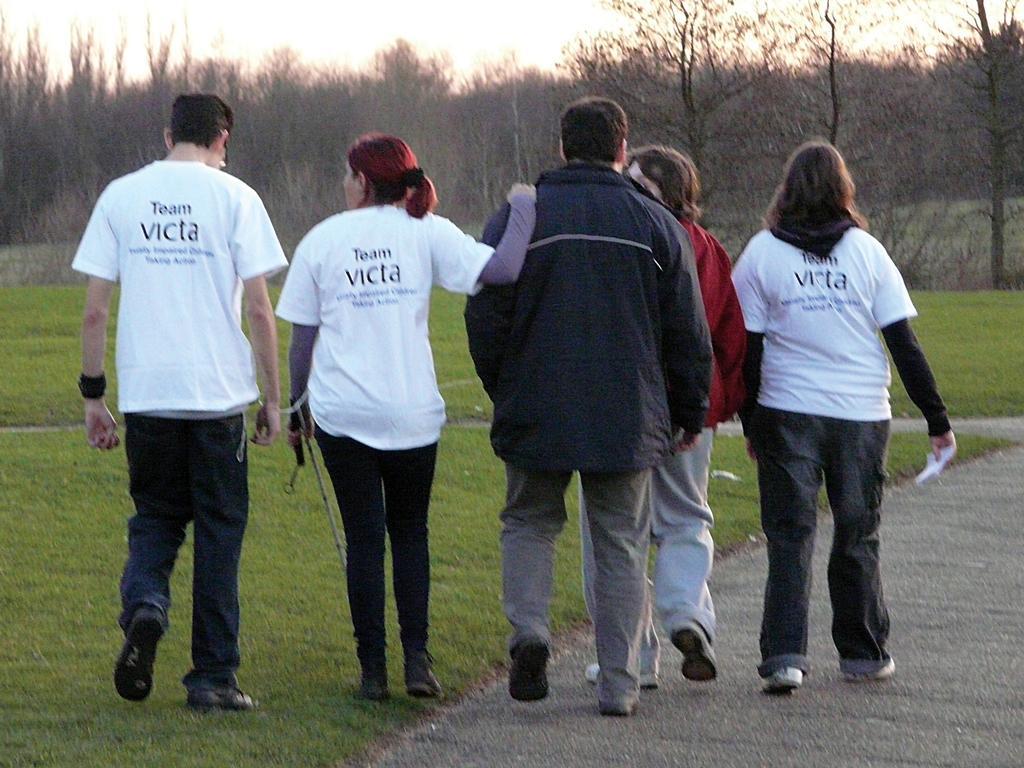In one or two sentences, can you explain what this image depicts? In this picture we can see a few people. We can see a person holding object on the right side. Some grass is visible on the ground. There are few trees in the background. 